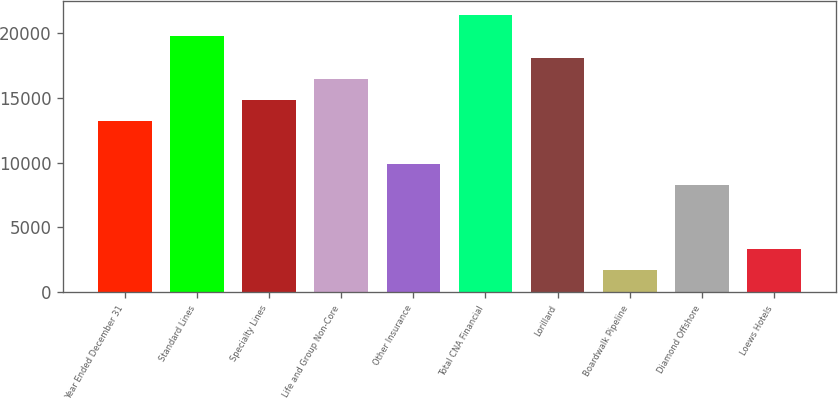<chart> <loc_0><loc_0><loc_500><loc_500><bar_chart><fcel>Year Ended December 31<fcel>Standard Lines<fcel>Specialty Lines<fcel>Life and Group Non-Core<fcel>Other Insurance<fcel>Total CNA Financial<fcel>Lorillard<fcel>Boardwalk Pipeline<fcel>Diamond Offshore<fcel>Loews Hotels<nl><fcel>13179.1<fcel>19740.3<fcel>14819.4<fcel>16459.7<fcel>9898.54<fcel>21380.6<fcel>18100<fcel>1697.09<fcel>8258.25<fcel>3337.38<nl></chart> 